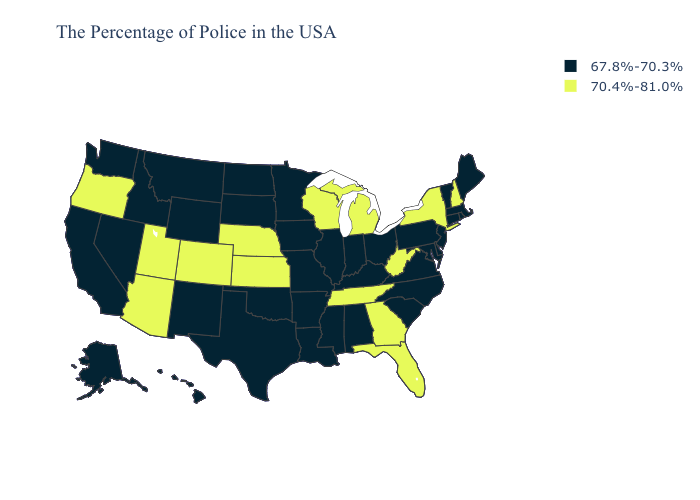What is the highest value in the USA?
Give a very brief answer. 70.4%-81.0%. Does Hawaii have a higher value than Montana?
Short answer required. No. What is the value of Tennessee?
Be succinct. 70.4%-81.0%. What is the highest value in states that border California?
Write a very short answer. 70.4%-81.0%. Among the states that border North Carolina , which have the lowest value?
Write a very short answer. Virginia, South Carolina. Name the states that have a value in the range 67.8%-70.3%?
Answer briefly. Maine, Massachusetts, Rhode Island, Vermont, Connecticut, New Jersey, Delaware, Maryland, Pennsylvania, Virginia, North Carolina, South Carolina, Ohio, Kentucky, Indiana, Alabama, Illinois, Mississippi, Louisiana, Missouri, Arkansas, Minnesota, Iowa, Oklahoma, Texas, South Dakota, North Dakota, Wyoming, New Mexico, Montana, Idaho, Nevada, California, Washington, Alaska, Hawaii. Is the legend a continuous bar?
Write a very short answer. No. What is the value of South Carolina?
Concise answer only. 67.8%-70.3%. Does Maryland have the highest value in the South?
Answer briefly. No. What is the lowest value in the USA?
Give a very brief answer. 67.8%-70.3%. What is the highest value in the USA?
Keep it brief. 70.4%-81.0%. What is the value of Montana?
Answer briefly. 67.8%-70.3%. What is the value of Illinois?
Keep it brief. 67.8%-70.3%. Which states hav the highest value in the South?
Be succinct. West Virginia, Florida, Georgia, Tennessee. 